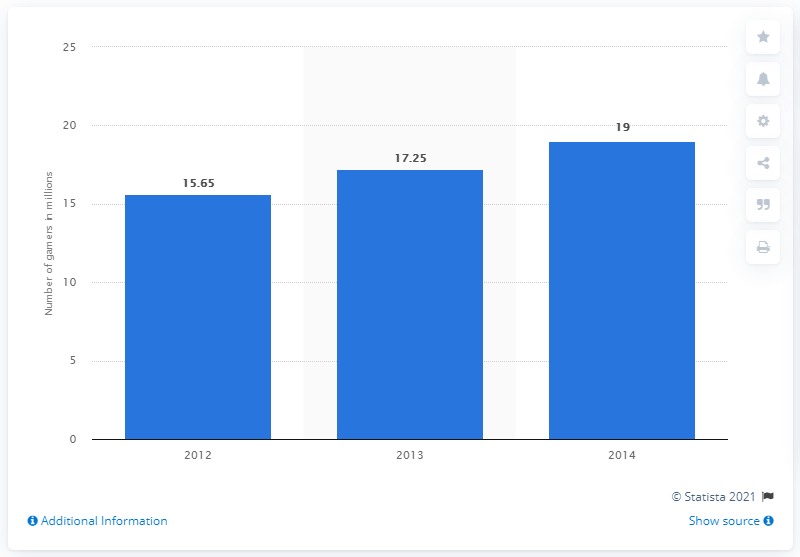Point out several critical features in this image. In 2012, there were approximately 15.65 online gamers in Vietnam. In 2014, it was projected that there would be 19 million online gamers in Vietnam. 